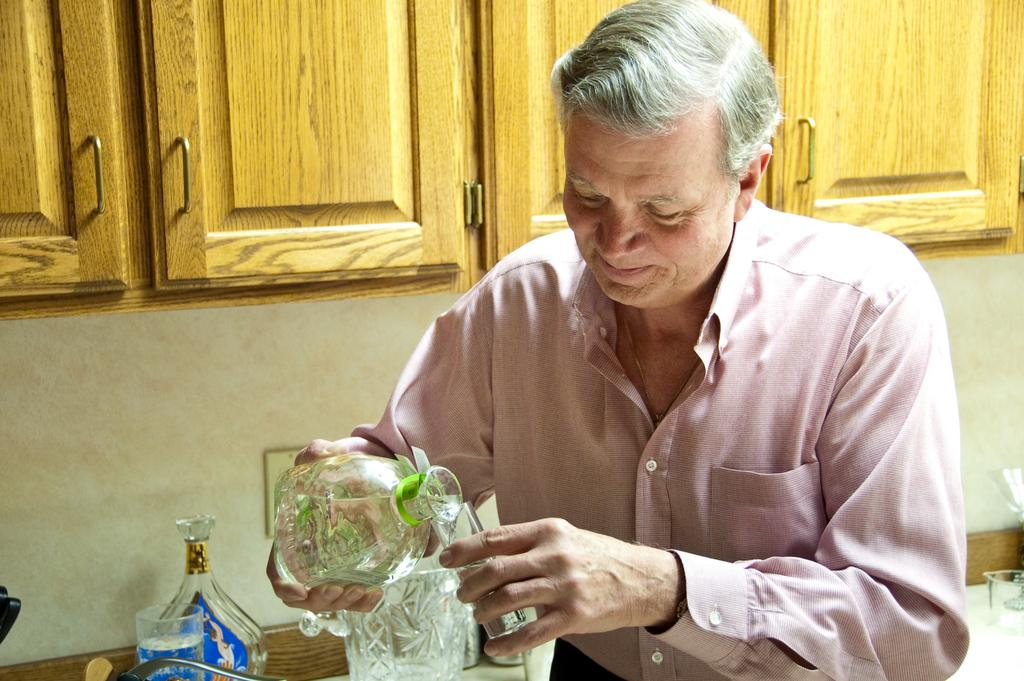Who is present in the image? There is a man in the image. What is the man doing in the image? The man is sitting in the image. What objects is the man holding? The man is holding a jar and a glass in the image. What can be seen in the background of the image? There are cupboards in the background of the image. What type of guitar is the man playing in the image? There is no guitar present in the image; the man is holding a jar and a glass. 